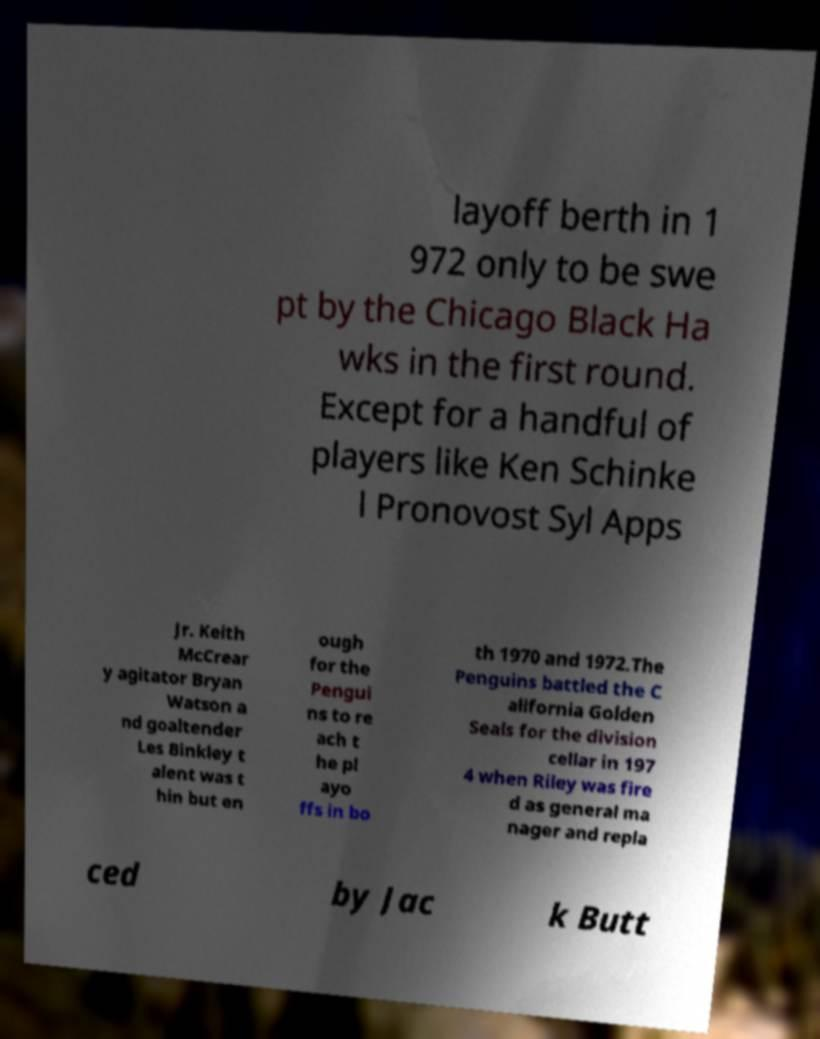Please identify and transcribe the text found in this image. layoff berth in 1 972 only to be swe pt by the Chicago Black Ha wks in the first round. Except for a handful of players like Ken Schinke l Pronovost Syl Apps Jr. Keith McCrear y agitator Bryan Watson a nd goaltender Les Binkley t alent was t hin but en ough for the Pengui ns to re ach t he pl ayo ffs in bo th 1970 and 1972.The Penguins battled the C alifornia Golden Seals for the division cellar in 197 4 when Riley was fire d as general ma nager and repla ced by Jac k Butt 